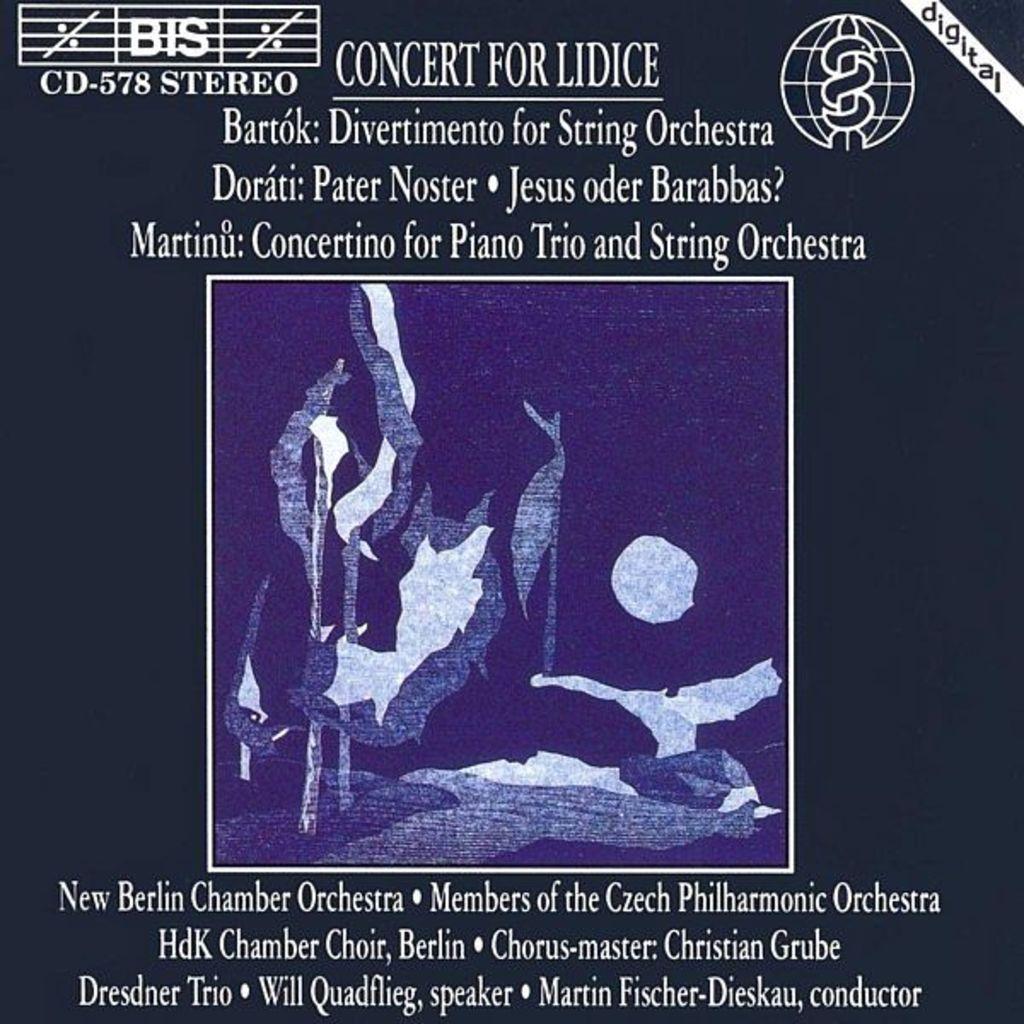What is on the setlist for this concert?
Offer a very short reply. New berlin chamber orchestra. Who is the speaker on this album?
Keep it short and to the point. Will quadflieg. 